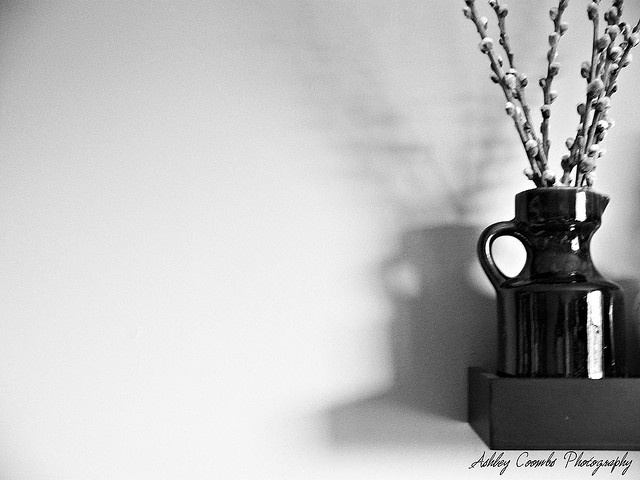Describe the objects in this image and their specific colors. I can see a vase in gray, black, white, and darkgray tones in this image. 